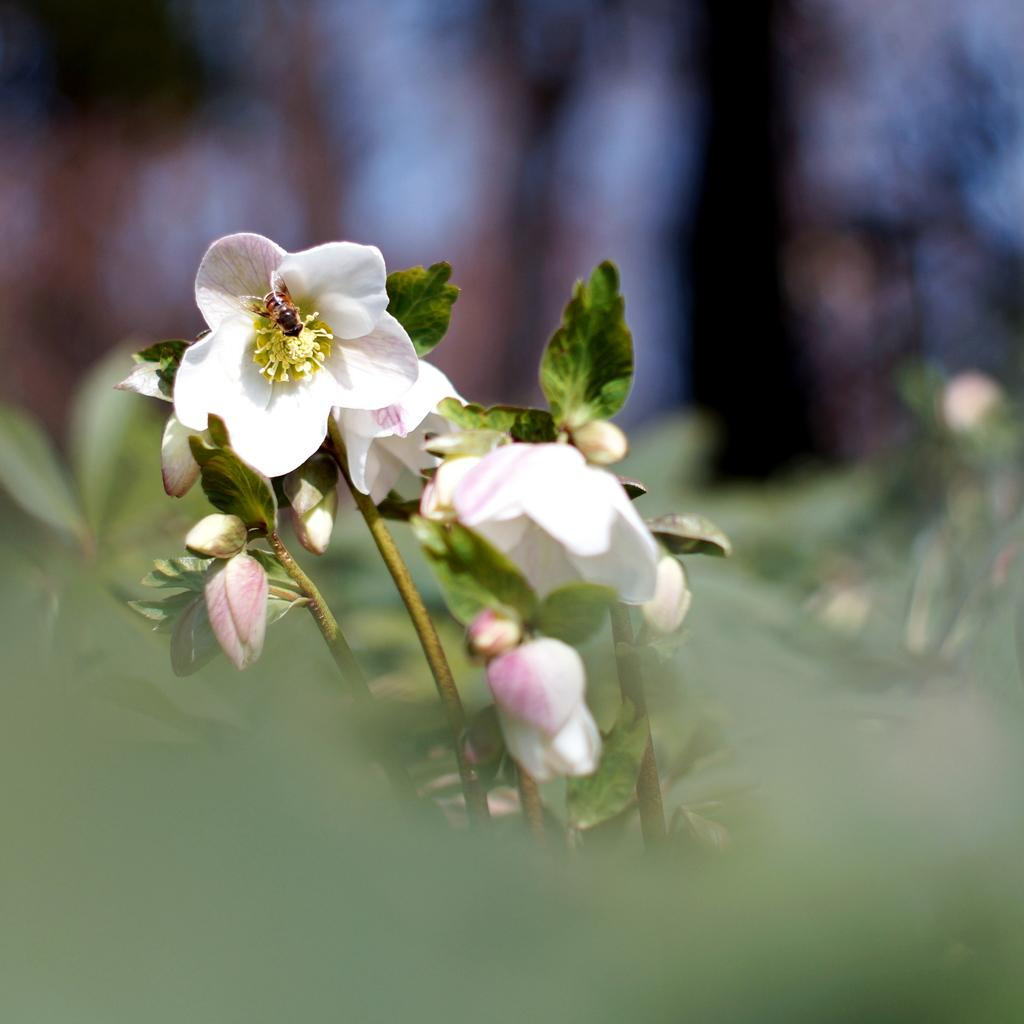What type of flowers are present in the image? There are white color flowers in the image. What other parts of the plants can be seen in the image? There are leaves and stems in the image. How many women are present in the image? There are no women present in the image; it features flowers, leaves, and stems. What is the plot of the story being told in the image? The image does not depict a story or plot; it is a still image of flowers, leaves, and stems. 